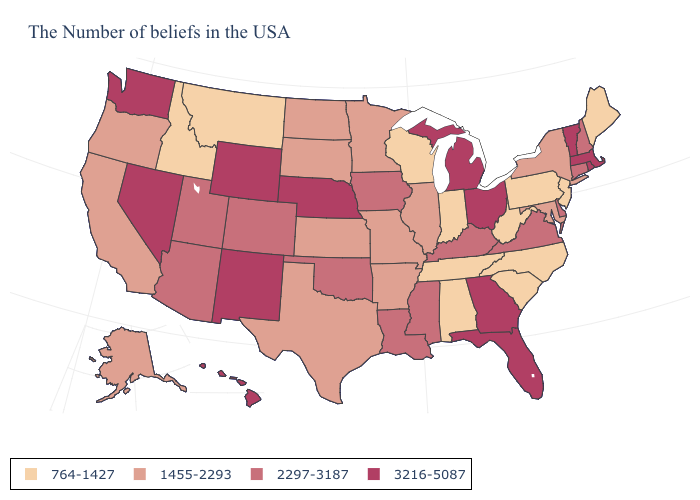Does the first symbol in the legend represent the smallest category?
Keep it brief. Yes. What is the value of West Virginia?
Write a very short answer. 764-1427. Which states hav the highest value in the Northeast?
Quick response, please. Massachusetts, Rhode Island, Vermont. Which states have the lowest value in the USA?
Quick response, please. Maine, New Jersey, Pennsylvania, North Carolina, South Carolina, West Virginia, Indiana, Alabama, Tennessee, Wisconsin, Montana, Idaho. Name the states that have a value in the range 3216-5087?
Give a very brief answer. Massachusetts, Rhode Island, Vermont, Ohio, Florida, Georgia, Michigan, Nebraska, Wyoming, New Mexico, Nevada, Washington, Hawaii. What is the lowest value in the USA?
Be succinct. 764-1427. Does Georgia have a higher value than Idaho?
Short answer required. Yes. Name the states that have a value in the range 1455-2293?
Be succinct. New York, Maryland, Illinois, Missouri, Arkansas, Minnesota, Kansas, Texas, South Dakota, North Dakota, California, Oregon, Alaska. What is the value of Arkansas?
Quick response, please. 1455-2293. Does New Jersey have the lowest value in the Northeast?
Give a very brief answer. Yes. Name the states that have a value in the range 764-1427?
Concise answer only. Maine, New Jersey, Pennsylvania, North Carolina, South Carolina, West Virginia, Indiana, Alabama, Tennessee, Wisconsin, Montana, Idaho. Which states hav the highest value in the Northeast?
Answer briefly. Massachusetts, Rhode Island, Vermont. Does Massachusetts have a higher value than Idaho?
Write a very short answer. Yes. Which states have the lowest value in the USA?
Be succinct. Maine, New Jersey, Pennsylvania, North Carolina, South Carolina, West Virginia, Indiana, Alabama, Tennessee, Wisconsin, Montana, Idaho. Name the states that have a value in the range 1455-2293?
Short answer required. New York, Maryland, Illinois, Missouri, Arkansas, Minnesota, Kansas, Texas, South Dakota, North Dakota, California, Oregon, Alaska. 